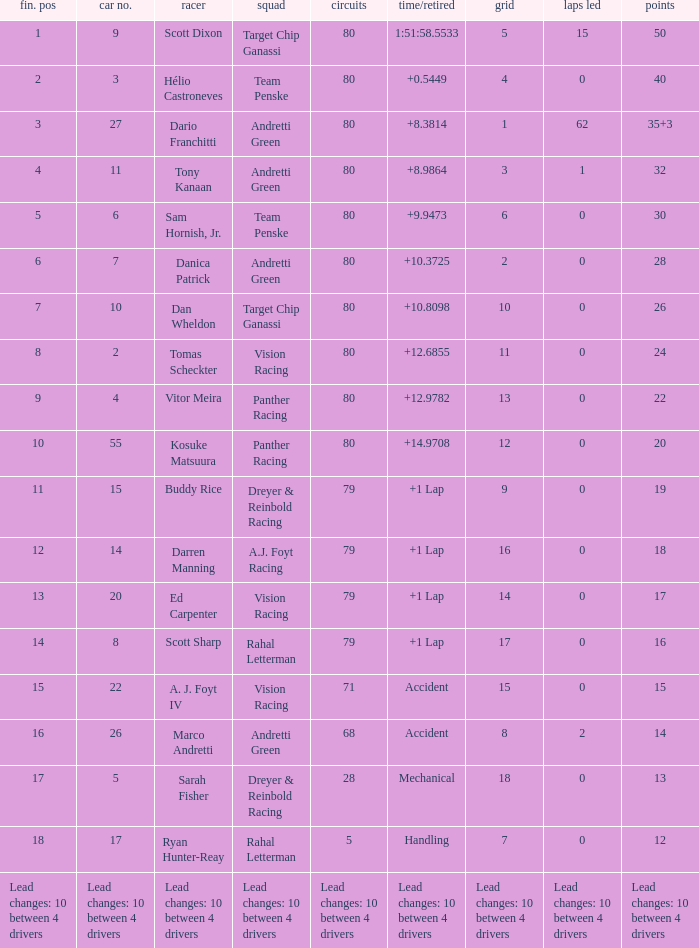How many points does driver kosuke matsuura have? 20.0. 